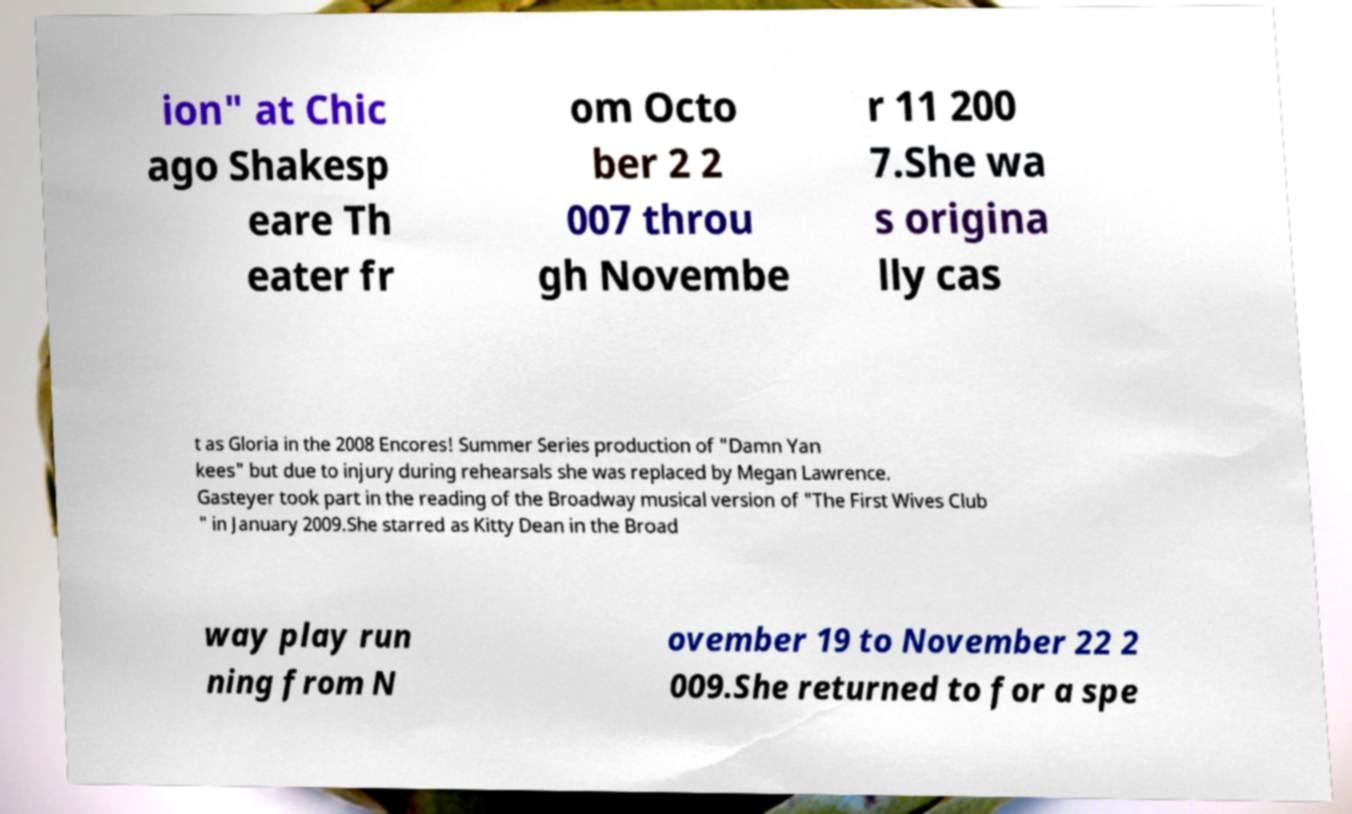There's text embedded in this image that I need extracted. Can you transcribe it verbatim? ion" at Chic ago Shakesp eare Th eater fr om Octo ber 2 2 007 throu gh Novembe r 11 200 7.She wa s origina lly cas t as Gloria in the 2008 Encores! Summer Series production of "Damn Yan kees" but due to injury during rehearsals she was replaced by Megan Lawrence. Gasteyer took part in the reading of the Broadway musical version of "The First Wives Club " in January 2009.She starred as Kitty Dean in the Broad way play run ning from N ovember 19 to November 22 2 009.She returned to for a spe 